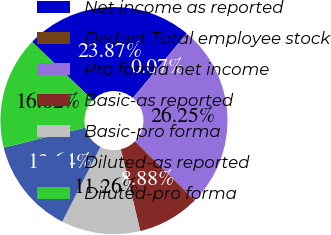Convert chart to OTSL. <chart><loc_0><loc_0><loc_500><loc_500><pie_chart><fcel>Net income as reported<fcel>Deduct Total employee stock<fcel>Pro forma net income<fcel>Basic-as reported<fcel>Basic-pro forma<fcel>Diluted-as reported<fcel>Diluted-pro forma<nl><fcel>23.87%<fcel>0.07%<fcel>26.25%<fcel>8.88%<fcel>11.26%<fcel>13.64%<fcel>16.02%<nl></chart> 